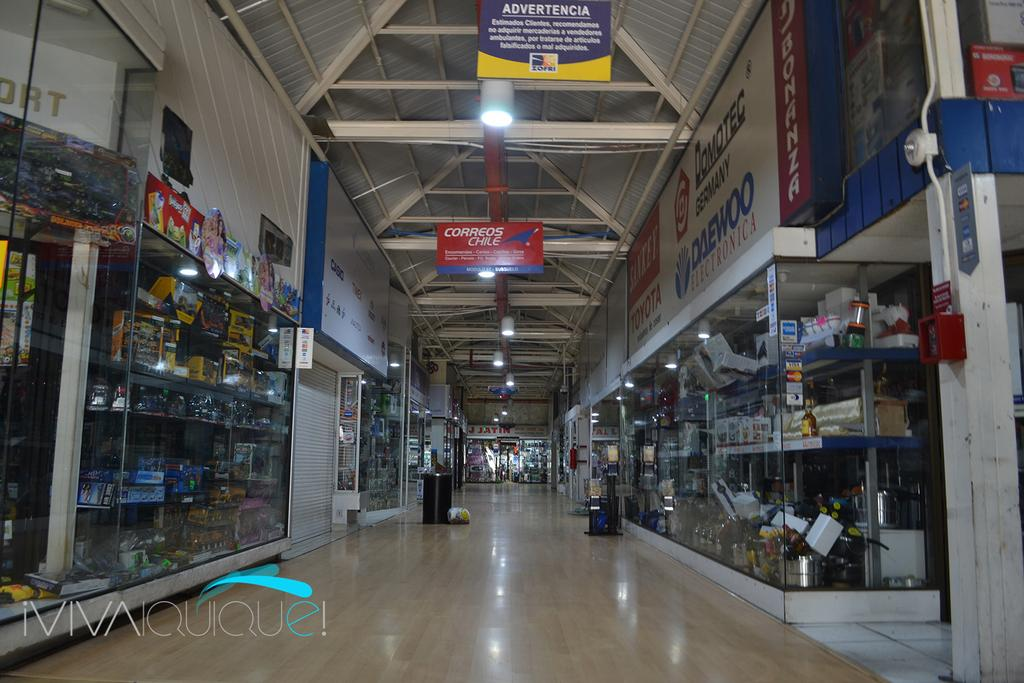<image>
Describe the image concisely. a sign at the top of the inside of a building that says 'advertencia' 